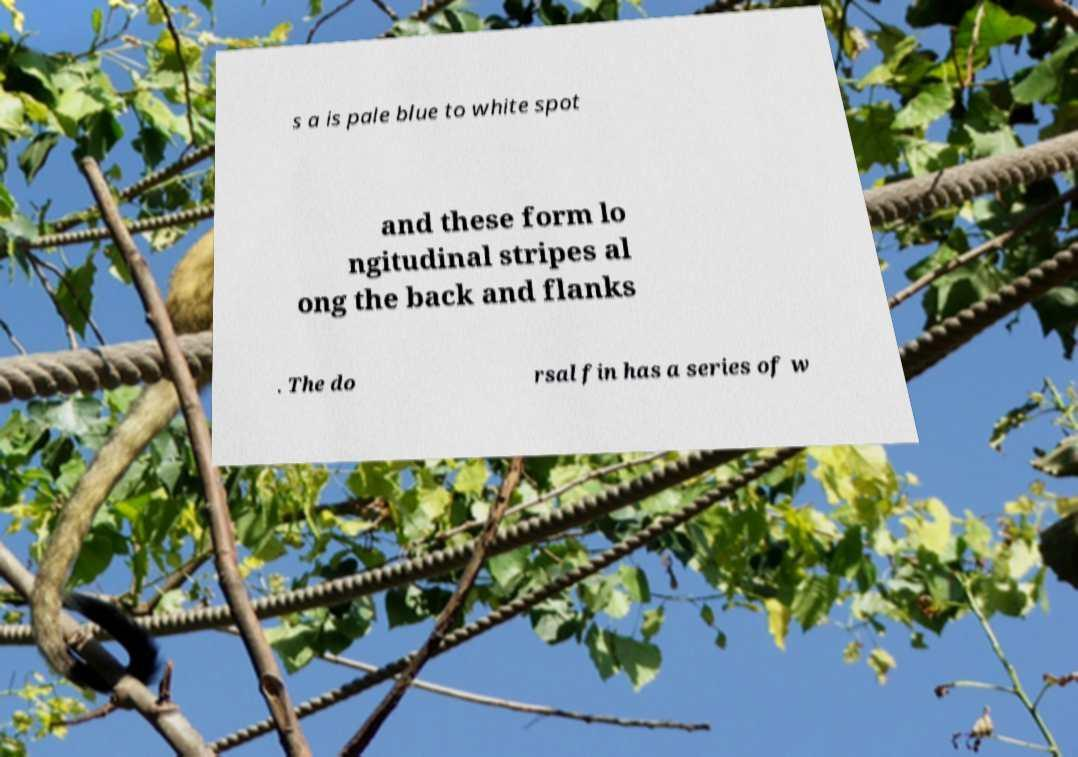Can you accurately transcribe the text from the provided image for me? s a is pale blue to white spot and these form lo ngitudinal stripes al ong the back and flanks . The do rsal fin has a series of w 